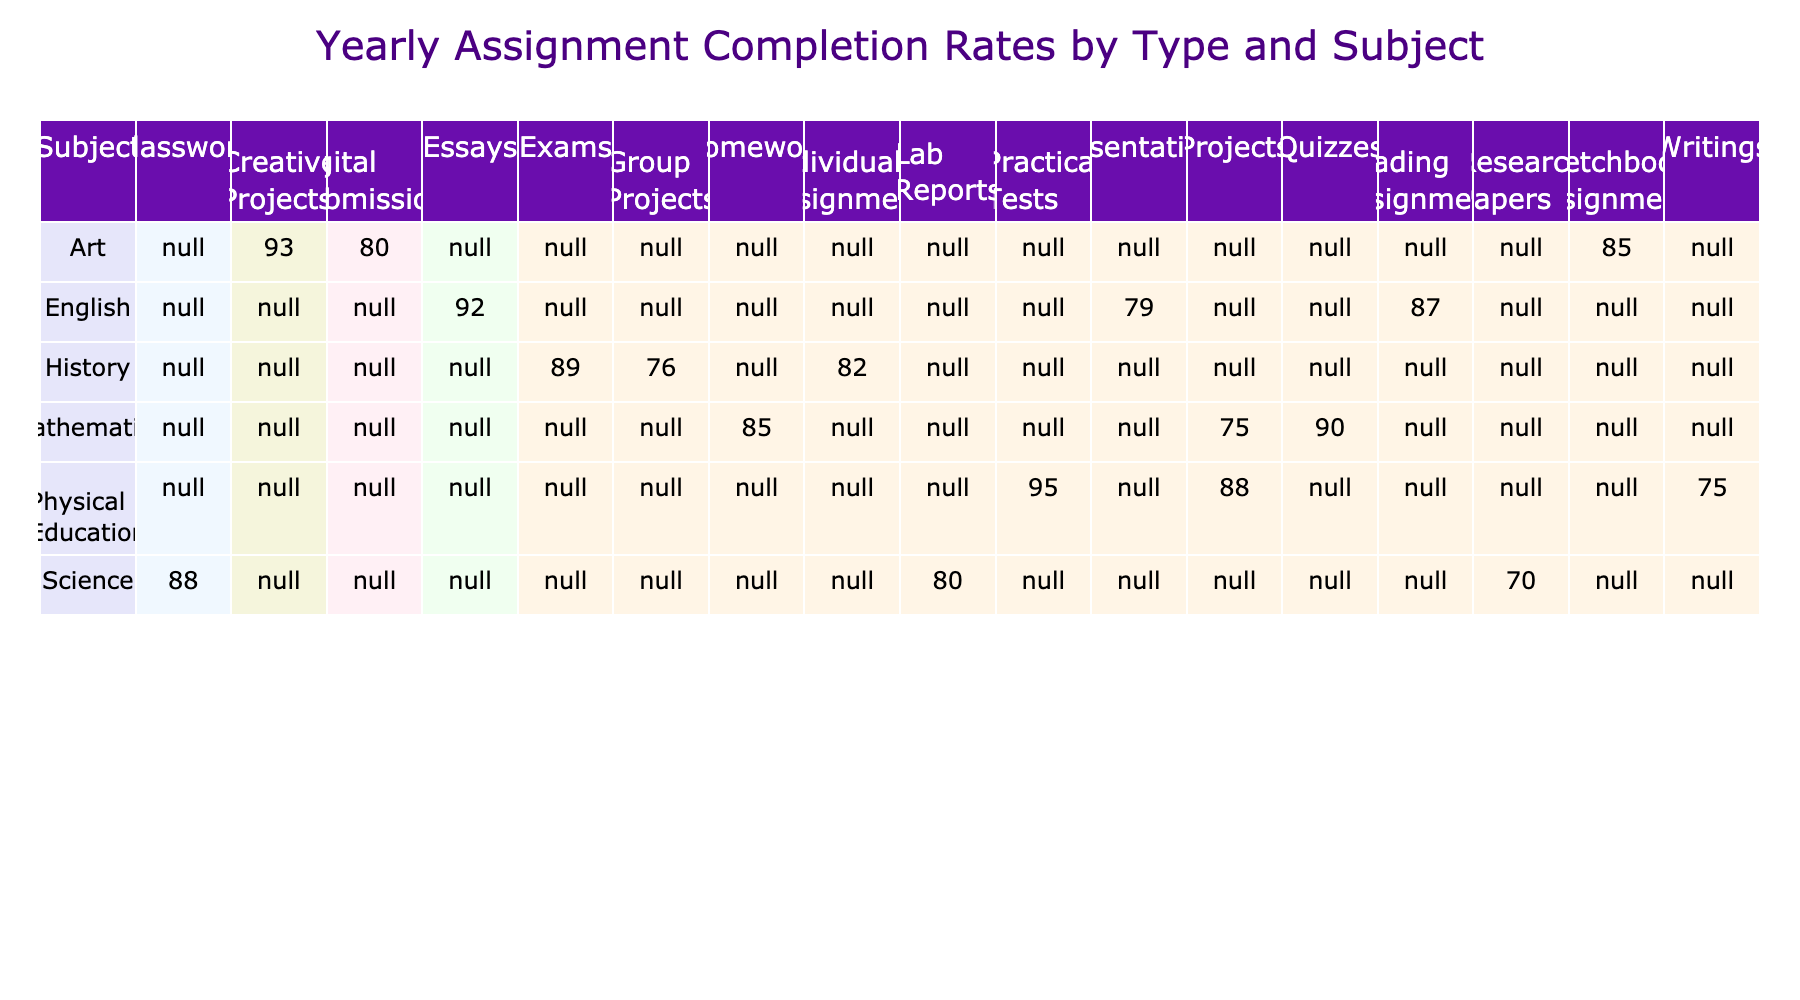What is the completion rate for Mathematics Homework? The table shows the completion rate for Mathematics Homework directly listed under the Mathematics row and the Homework column. Thus, it can be retrieved as 85%.
Answer: 85% Which assignment type has the highest completion rate in English? By looking at the English row, we can compare the completion rates of Essays (92%), Reading Assignments (87%), and Presentations (79%). The highest value is for Essays at 92%.
Answer: 92% What is the average completion rate for all assignment types in Science? The completion rates for Science are Lab Reports (80%), Classwork (88%), and Research Papers (70%). To find the average, we sum these rates (80 + 88 + 70 = 238) and divide by the number of assignment types (3), which gives us 238 / 3 = 79.33%.
Answer: 79.33% Is the completion rate for Physical Education Practical Tests higher than that for History Exams? The completion rate for Physical Education Practical Tests is 95%, while for History Exams it is 89%. Since 95% is greater than 89%, we can conclude that this statement is true.
Answer: Yes Which subject has the lowest average completion rate across all assignment types? To find the subject with the lowest average, we need to calculate the average completion rates for each subject: Mathematics (85 + 75 + 90) / 3 = 83.33, Science (80 + 88 + 70) / 3 = 79.33, English (92 + 87 + 79) / 3 = 86, History (76 + 82 + 89) / 3 = 82.33, Art (93 + 85 + 80) / 3 = 86, and Physical Education (95 + 75 + 88) / 3 = 86.33. The lowest average is for Science at 79.33%.
Answer: Science What is the difference in completion rates between the highest and lowest assignment types in Art? The highest completion rate in Art is for Creative Projects at 93%, and the lowest is for Digital Submissions at 80%. The difference is calculated as 93 - 80 = 13%.
Answer: 13% 